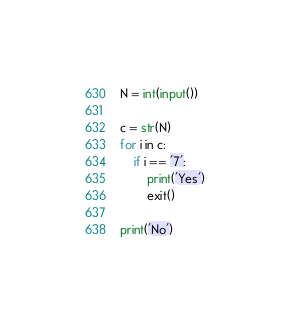<code> <loc_0><loc_0><loc_500><loc_500><_Python_>N = int(input())

c = str(N)
for i in c:
	if i == '7':
		print('Yes')
		exit()
	
print('No')</code> 